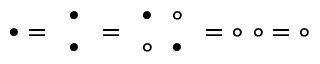Convert formula to latex. <formula><loc_0><loc_0><loc_500><loc_500>\bullet = { \begin{array} { l } { \bullet } \\ { \bullet } \end{array} } = { \begin{array} { l } { \bullet \quad c i r c } \\ { \circ \quad b u l l e t } \end{array} } = \circ \ \circ = \circ</formula> 